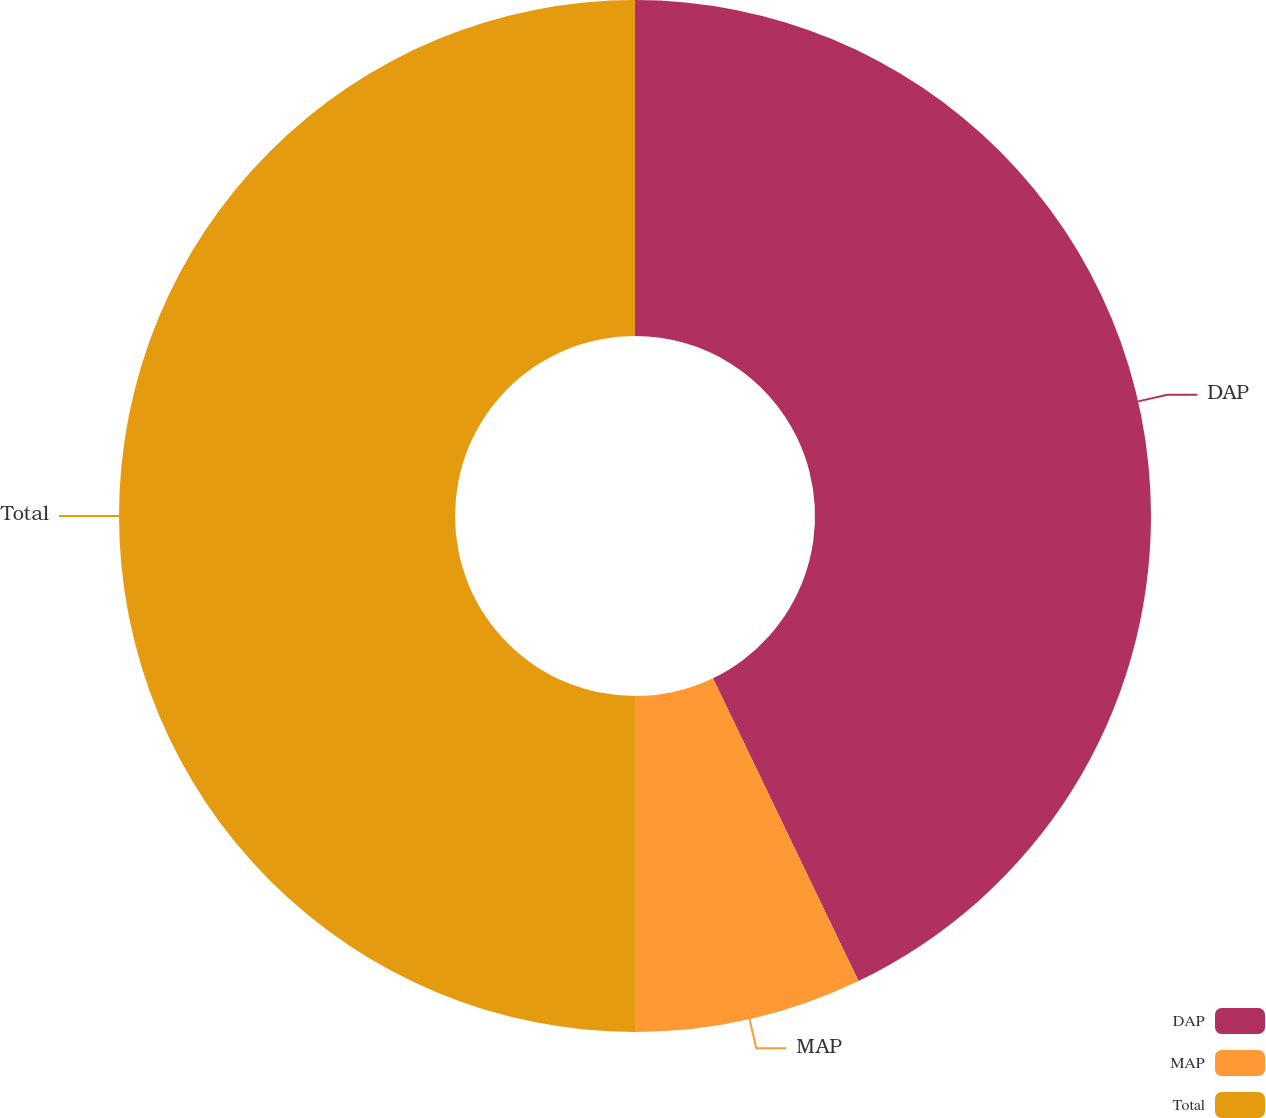<chart> <loc_0><loc_0><loc_500><loc_500><pie_chart><fcel>DAP<fcel>MAP<fcel>Total<nl><fcel>42.87%<fcel>7.13%<fcel>50.0%<nl></chart> 